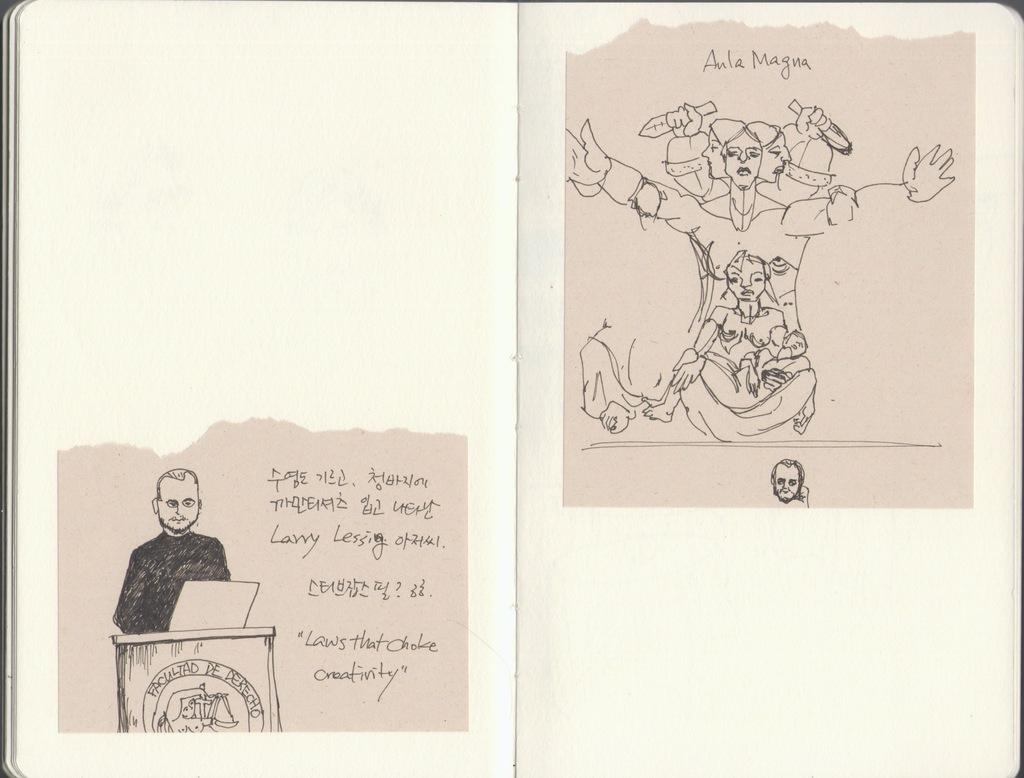What object is present in the image? There is a book in the image. What is the book made of? The book has paper. What can be found on the paper within the book? There are quotes and drawings on the paper. What is the value of the thought process depicted in the image? There is no specific thought process depicted in the image, as it only shows a book with quotes and drawings on the paper. 